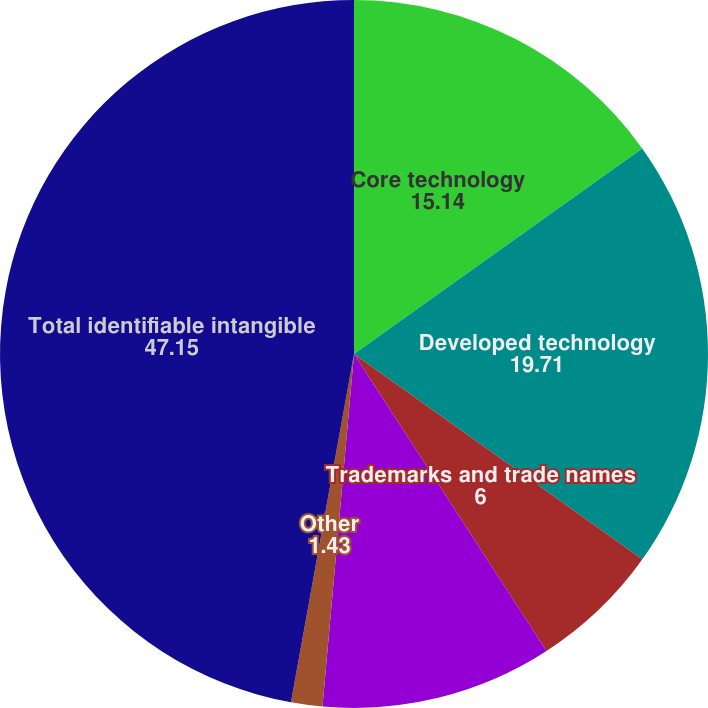<chart> <loc_0><loc_0><loc_500><loc_500><pie_chart><fcel>Core technology<fcel>Developed technology<fcel>Trademarks and trade names<fcel>Customer relationships<fcel>Other<fcel>Total identifiable intangible<nl><fcel>15.14%<fcel>19.71%<fcel>6.0%<fcel>10.57%<fcel>1.43%<fcel>47.15%<nl></chart> 